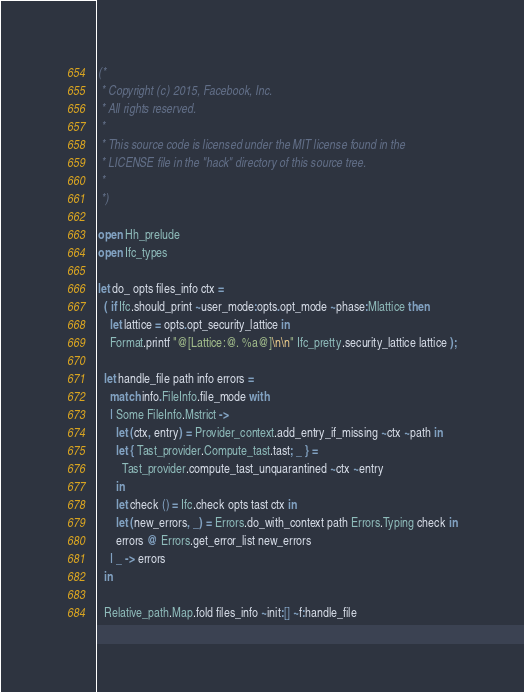<code> <loc_0><loc_0><loc_500><loc_500><_OCaml_>(*
 * Copyright (c) 2015, Facebook, Inc.
 * All rights reserved.
 *
 * This source code is licensed under the MIT license found in the
 * LICENSE file in the "hack" directory of this source tree.
 *
 *)

open Hh_prelude
open Ifc_types

let do_ opts files_info ctx =
  ( if Ifc.should_print ~user_mode:opts.opt_mode ~phase:Mlattice then
    let lattice = opts.opt_security_lattice in
    Format.printf "@[Lattice:@. %a@]\n\n" Ifc_pretty.security_lattice lattice );

  let handle_file path info errors =
    match info.FileInfo.file_mode with
    | Some FileInfo.Mstrict ->
      let (ctx, entry) = Provider_context.add_entry_if_missing ~ctx ~path in
      let { Tast_provider.Compute_tast.tast; _ } =
        Tast_provider.compute_tast_unquarantined ~ctx ~entry
      in
      let check () = Ifc.check opts tast ctx in
      let (new_errors, _) = Errors.do_with_context path Errors.Typing check in
      errors @ Errors.get_error_list new_errors
    | _ -> errors
  in

  Relative_path.Map.fold files_info ~init:[] ~f:handle_file
</code> 